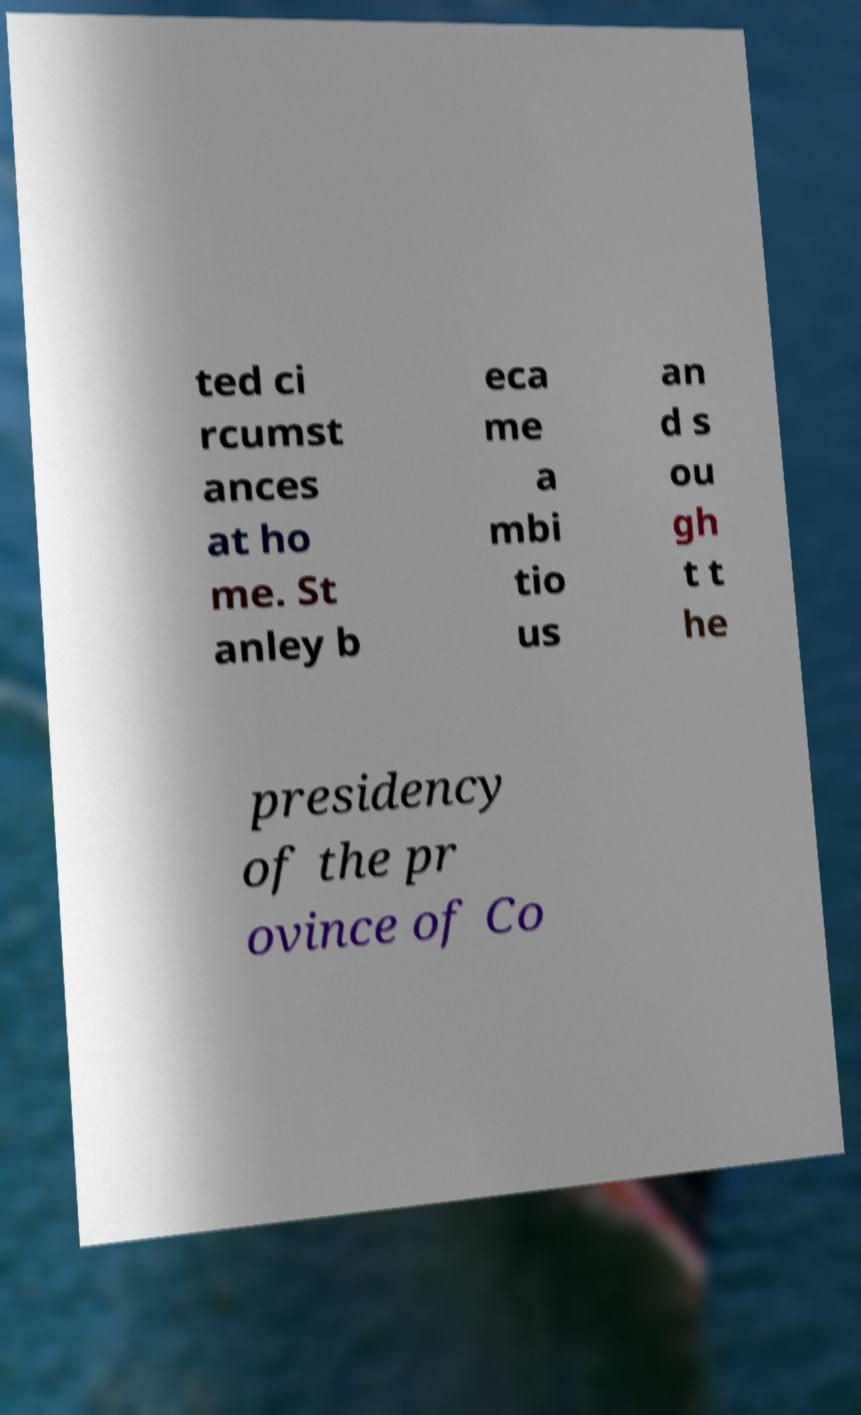I need the written content from this picture converted into text. Can you do that? ted ci rcumst ances at ho me. St anley b eca me a mbi tio us an d s ou gh t t he presidency of the pr ovince of Co 